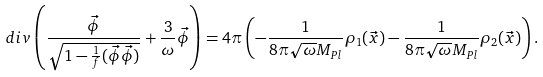<formula> <loc_0><loc_0><loc_500><loc_500>d i v \left ( \frac { \vec { \phi } } { \sqrt { 1 - \frac { 1 } { f } ( { \vec { \phi } } { \vec { \phi } } ) } } + \frac { 3 } { \omega } \vec { \phi } \right ) = 4 \pi \left ( - \frac { 1 } { 8 \pi \sqrt { \omega } M _ { P l } } \rho _ { 1 } ( \vec { x } ) - \frac { 1 } { 8 \pi \sqrt { \omega } M _ { P l } } \rho _ { 2 } ( \vec { x } ) \right ) .</formula> 